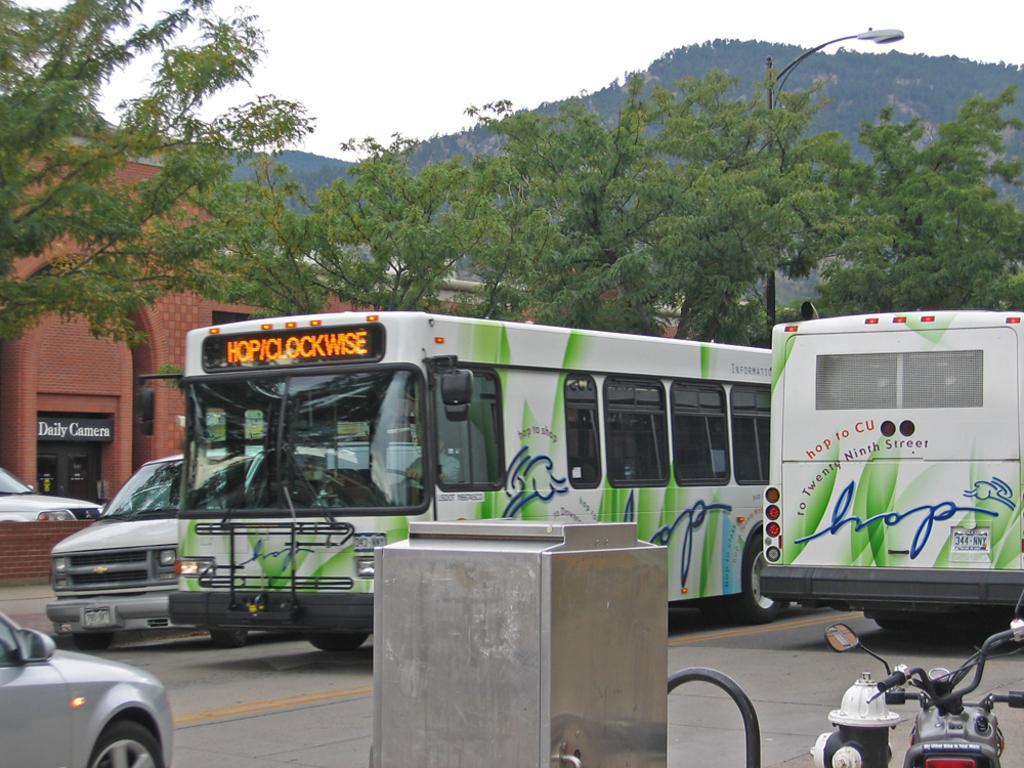Describe this image in one or two sentences. This image is clicked outside. There are vehicles in the middle. There are trees in the middle. There is sky at the top. There is a bike in the bottom right corner. There is building on the left side. 